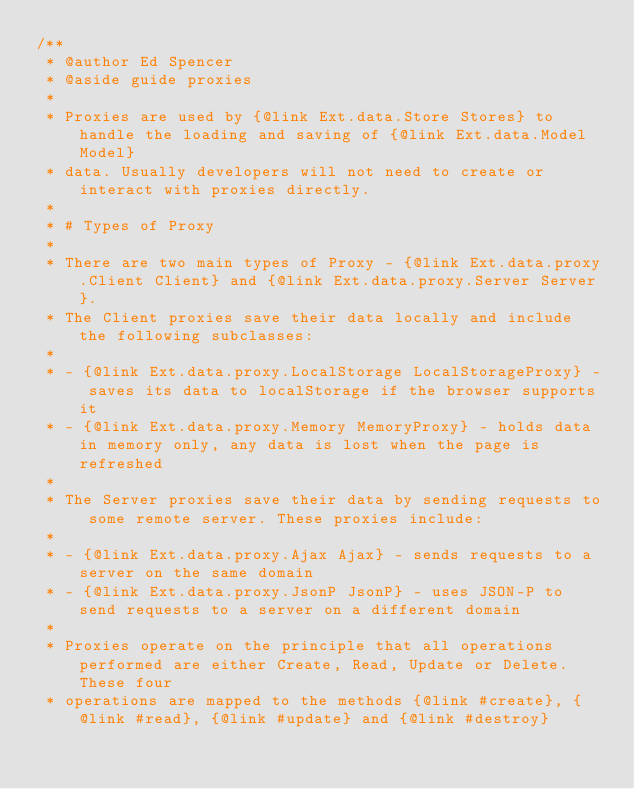Convert code to text. <code><loc_0><loc_0><loc_500><loc_500><_JavaScript_>/**
 * @author Ed Spencer
 * @aside guide proxies
 *
 * Proxies are used by {@link Ext.data.Store Stores} to handle the loading and saving of {@link Ext.data.Model Model}
 * data. Usually developers will not need to create or interact with proxies directly.
 *
 * # Types of Proxy
 *
 * There are two main types of Proxy - {@link Ext.data.proxy.Client Client} and {@link Ext.data.proxy.Server Server}.
 * The Client proxies save their data locally and include the following subclasses:
 *
 * - {@link Ext.data.proxy.LocalStorage LocalStorageProxy} - saves its data to localStorage if the browser supports it
 * - {@link Ext.data.proxy.Memory MemoryProxy} - holds data in memory only, any data is lost when the page is refreshed
 *
 * The Server proxies save their data by sending requests to some remote server. These proxies include:
 *
 * - {@link Ext.data.proxy.Ajax Ajax} - sends requests to a server on the same domain
 * - {@link Ext.data.proxy.JsonP JsonP} - uses JSON-P to send requests to a server on a different domain
 *
 * Proxies operate on the principle that all operations performed are either Create, Read, Update or Delete. These four
 * operations are mapped to the methods {@link #create}, {@link #read}, {@link #update} and {@link #destroy}</code> 